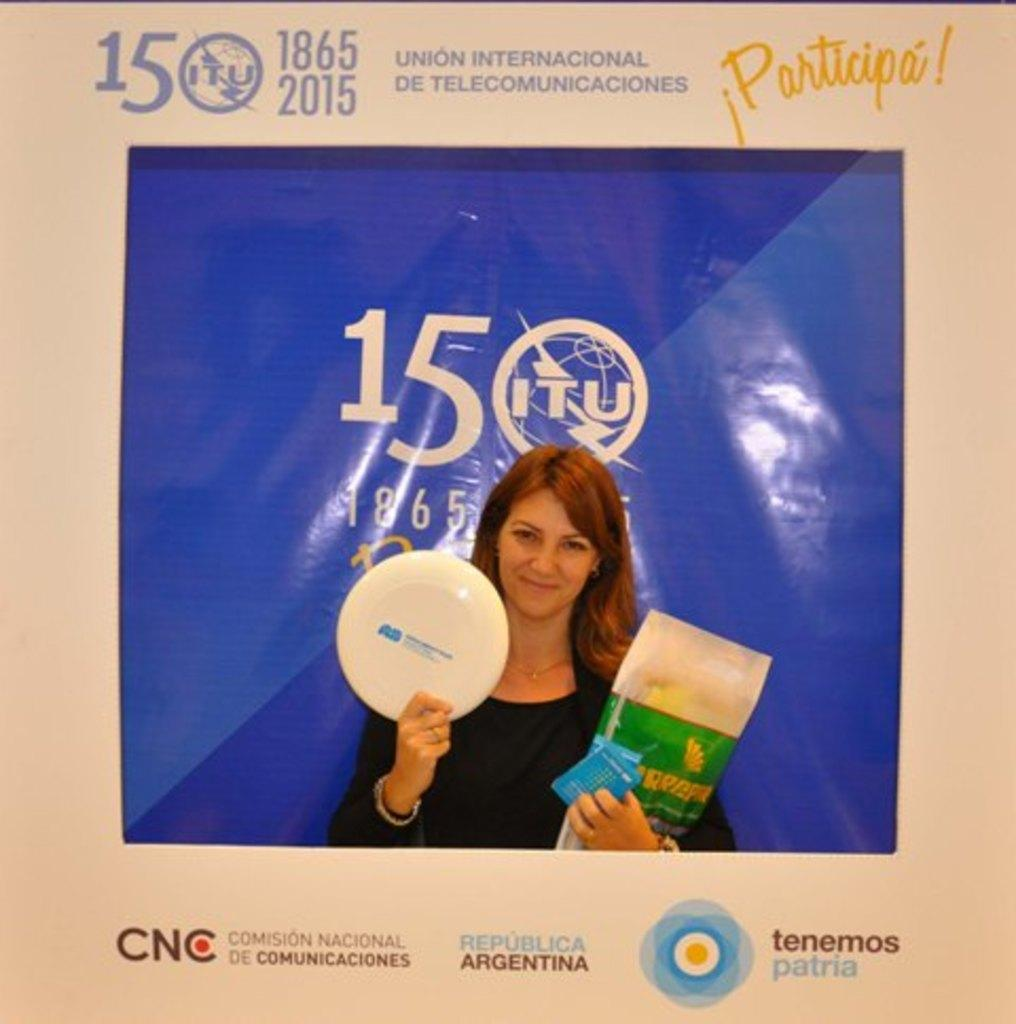What is featured on the poster in the image? There is a poster in the image that contains a picture of a person. What is the person in the picture doing? The person in the picture is holding objects. What other elements are present on the poster besides the picture? There are words, numbers, and logos on the poster. What type of popcorn is being served in the image? There is no popcorn present in the image; it only features a poster with a picture of a person holding objects. What color is the silver object being held by the person in the image? There is no silver object present in the image; the person is holding unspecified objects. 